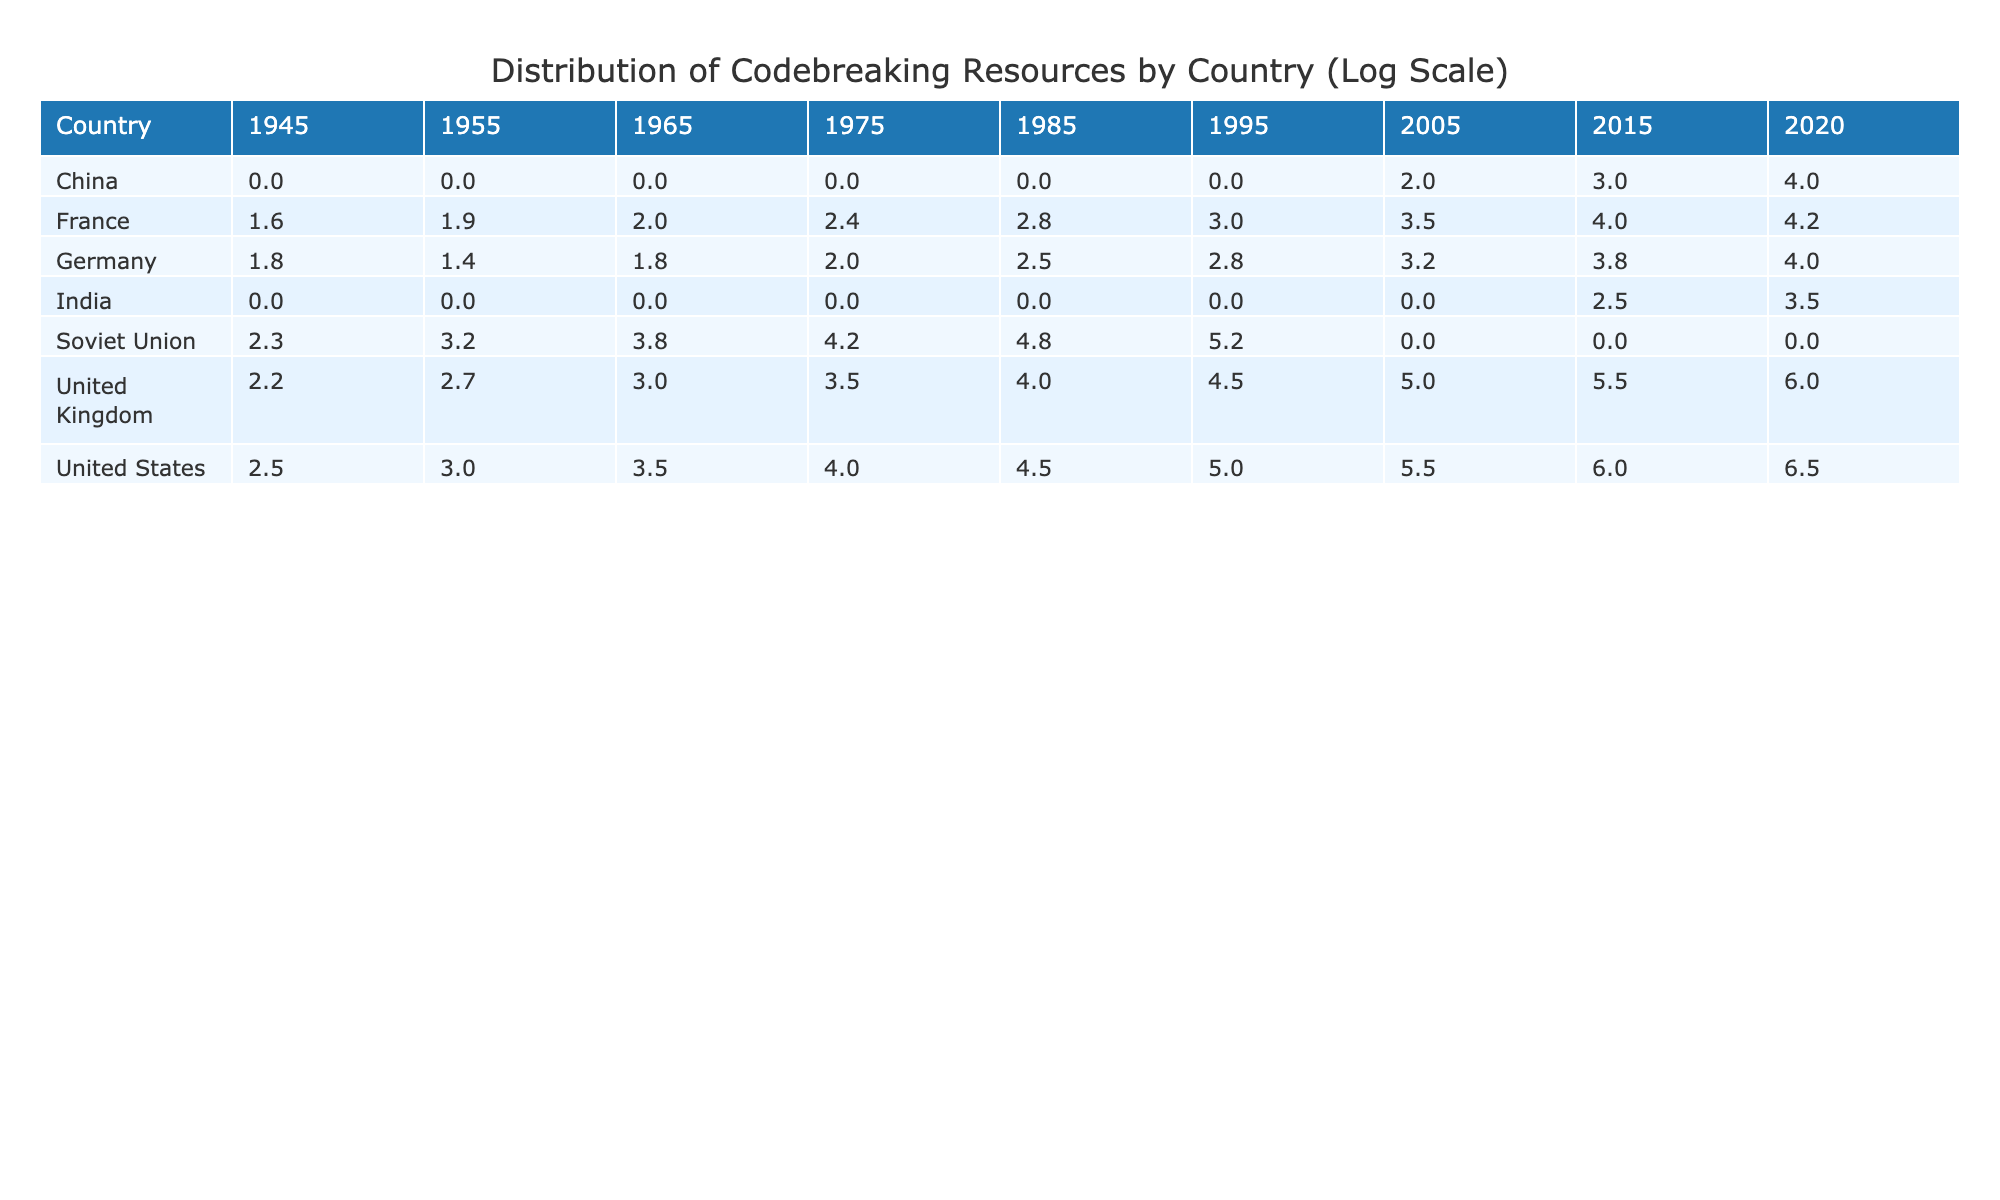What was the highest allocation of codebreaking resources in 2020? In 2020, the United States had the highest allocation of codebreaking resources, which is 6.5 on the log scale. I can see this value by scanning the 2020 column in the table.
Answer: 6.5 Which country had the lowest codebreaking resources in 1955? In 1955, Germany had the lowest allocation of codebreaking resources, with a value of 1.4 on the log scale. By comparing the values across all countries for that year, it stands out as the smallest.
Answer: 1.4 What is the average allocation of codebreaking resources for the United Kingdom from 1945 to 2020? To calculate the average for the United Kingdom, I sum the values for the years, which are 2.2, 2.7, 3.0, 3.5, 4.0, 4.5, 5.0, 5.5, and 6.0. This gives a total of 37.4. There are 9 data points (one for each year), so I divide 37.4 by 9 to get an average of approximately 4.16.
Answer: 4.16 Did the codebreaking resources for the Soviet Union increase more than those for France from 1945 to 1995? To evaluate the increase, I look at the values for both countries in 1945 and 1995. The Soviet Union had 2.3 in 1945 and 5.2 in 1995, showing an increase of 2.9. France had 1.6 in 1945 and 3.0 in 1995, showing an increase of 1.4. Since 2.9 is greater than 1.4, the answer is yes.
Answer: Yes In which decade did Germany experience the highest allocation of codebreaking resources? To find this, I take note of the highest values recorded for Germany across the decades. In the 1975 entry, Germany had an allocation of 2.0, which is the highest compared to the values in other decades. Checking the rows, I confirm all the values for Germany are less than 2.0 in other decades.
Answer: 1975 What was the trend in overall resource allocation for the United States from 1945 to 2020? By observing the values assigned to the United States for each year, we see an increase from 2.5 in 1945 to 6.5 in 2020. The trend is positive throughout the years as each subsequent value shows a consistent increase compared to the previous years.
Answer: Increasing 